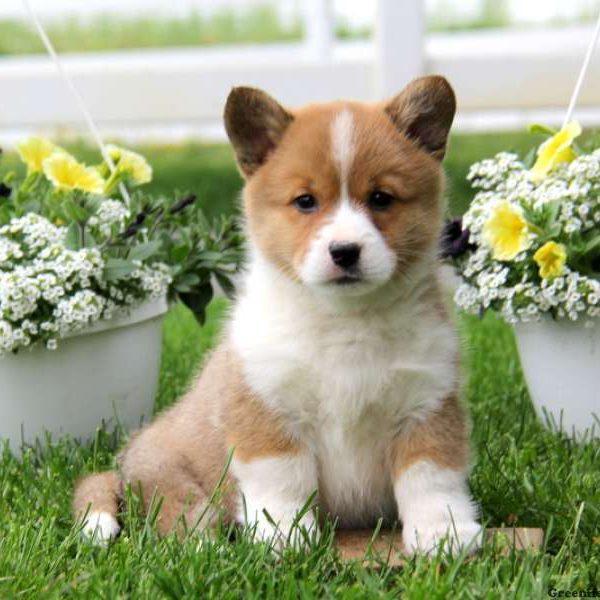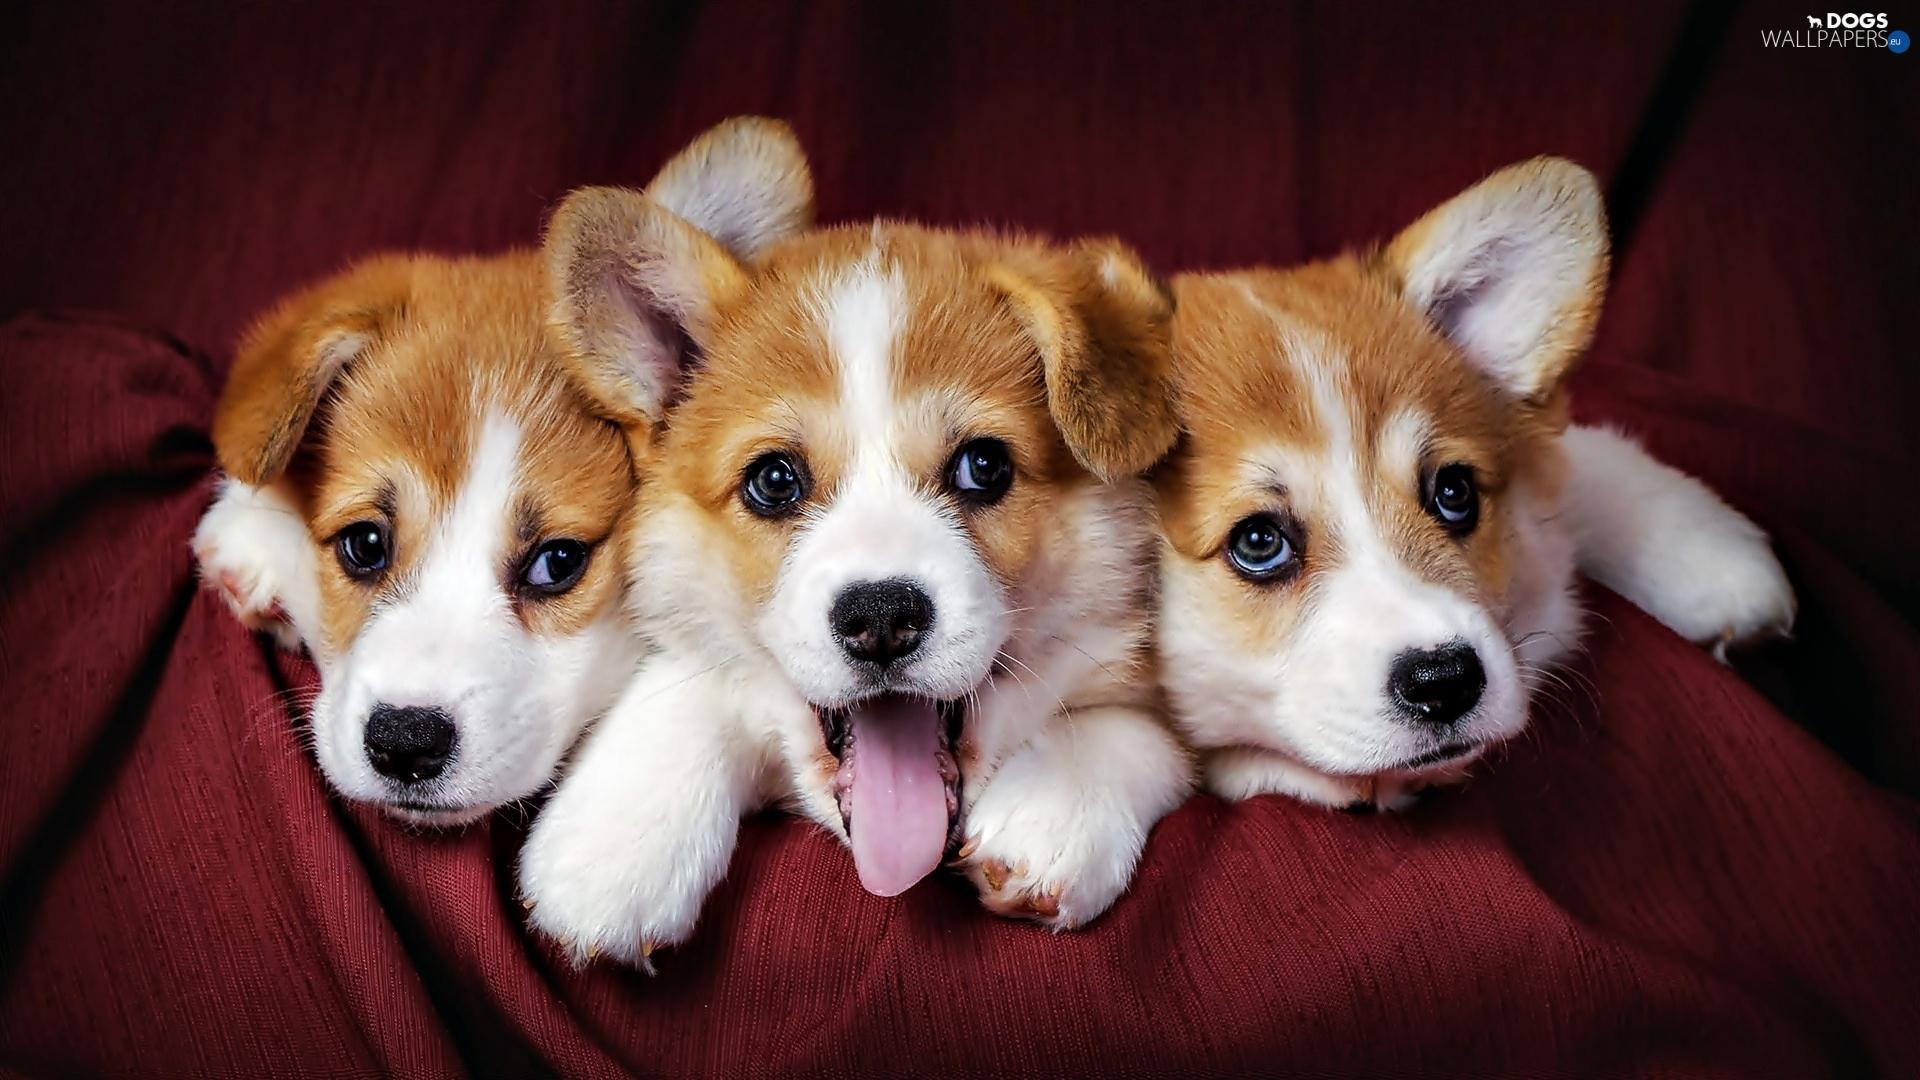The first image is the image on the left, the second image is the image on the right. Considering the images on both sides, is "An image shows at least three similarly sized dogs posed in a row." valid? Answer yes or no. Yes. 